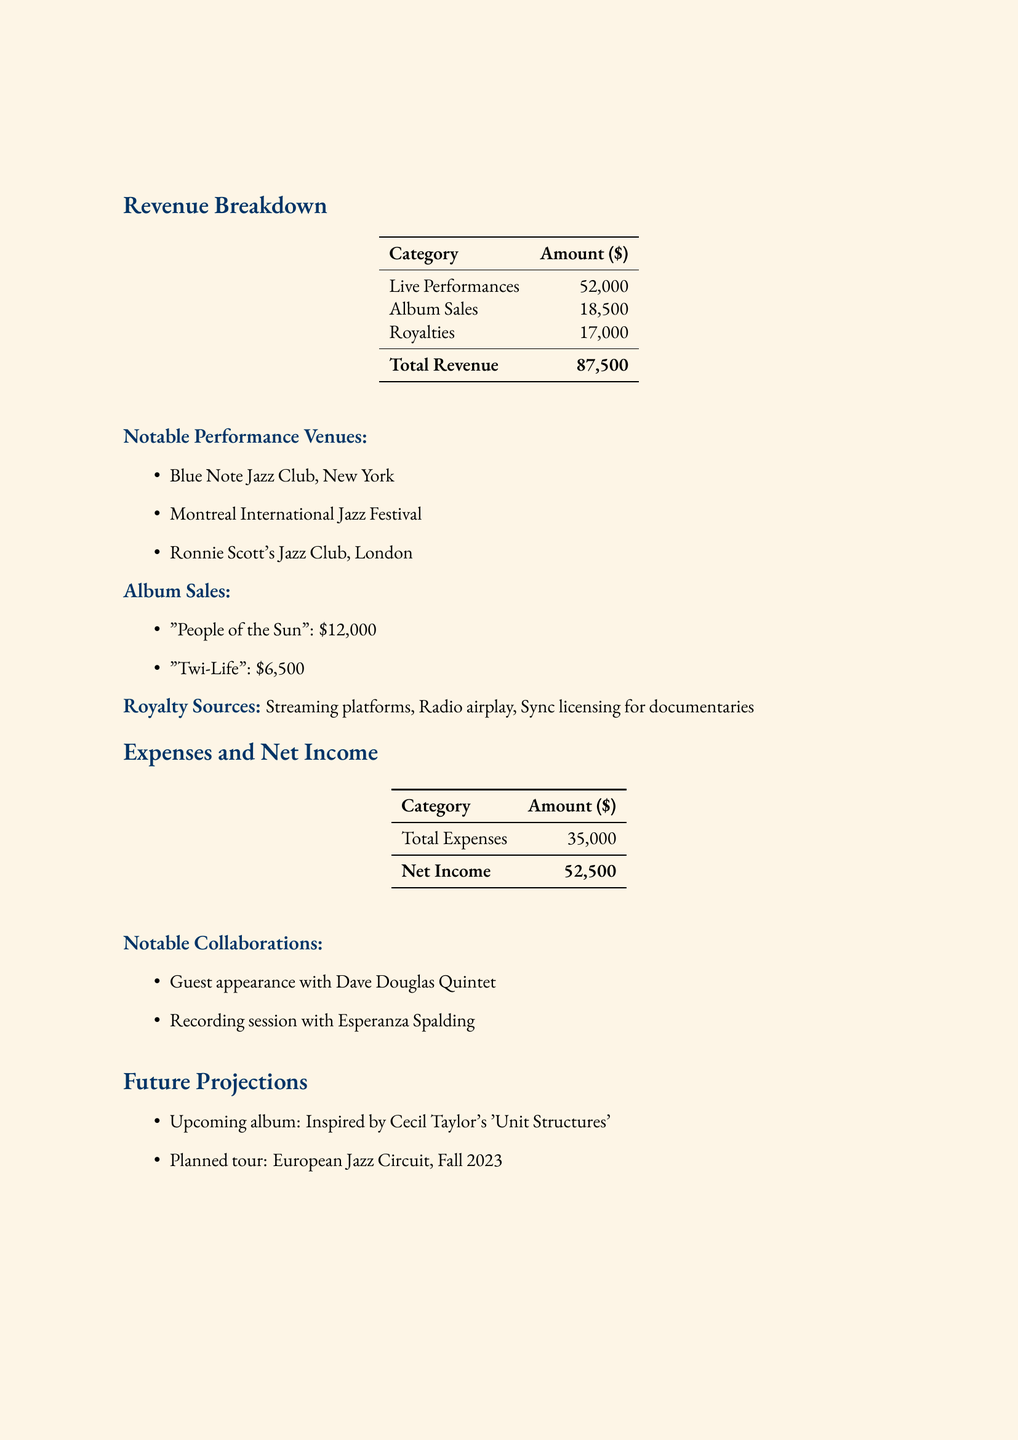what was the total revenue for 2022? The total revenue is explicitly stated in the document as $87,500.
Answer: $87,500 how much revenue did live performances generate? Live performances revenue is provided separately in the revenue breakdown, totaling $52,000.
Answer: $52,000 which two albums contributed to album sales? The album sales section lists two albums, allowing for identification of their titles as "People of the Sun" and "Twi-Life."
Answer: "People of the Sun" and "Twi-Life" what is the total amount earned from royalties? The document specifies the royalty total as $17,000 in the revenue breakdown.
Answer: $17,000 list one of the notable venues where performances took place. The notable venues are explicitly listed, for example, "Blue Note Jazz Club, New York".
Answer: Blue Note Jazz Club, New York what were the total expenses recorded? The total expenses are mentioned directly in the document as $35,000.
Answer: $35,000 what was the net income generated in 2022? The net income is calculated in the document, provided as $52,500.
Answer: $52,500 who collaborated with Marcus Strickland in 2022? Notable collaborations are listed in the document including the names of artists like Dave Douglas and Esperanza Spalding.
Answer: Dave Douglas Quintet and Esperanza Spalding what is the planned tour destination for fall 2023? The document states the planned tour is the "European Jazz Circuit."
Answer: European Jazz Circuit 